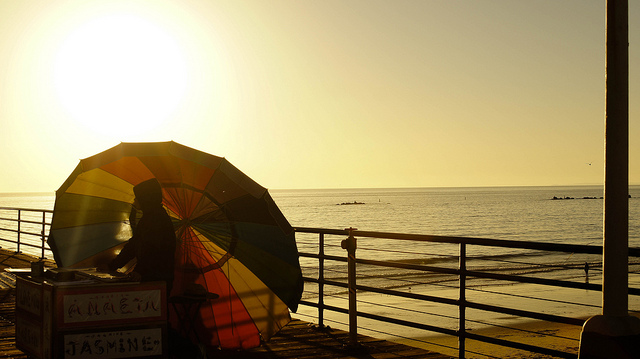Could you tell me more about the sign by the umbrella? While the details of the sign are not clearly visible, it appears to display the name 'JASMINE' and some other text that may indicate the nature of a small business, potentially offering goods or services to people on the promenade. The sign, coupled with the umbrella, suggests a local vendor or a beachside service. Its presence adds a layer of local charm and economic activity to the tranquil seaside atmosphere. 